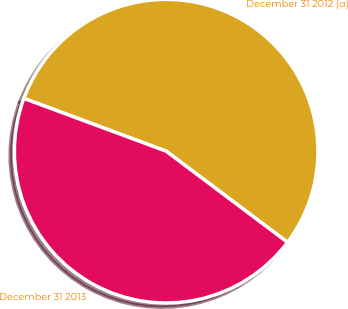<chart> <loc_0><loc_0><loc_500><loc_500><pie_chart><fcel>December 31 2012 (a)<fcel>December 31 2013<nl><fcel>54.6%<fcel>45.4%<nl></chart> 